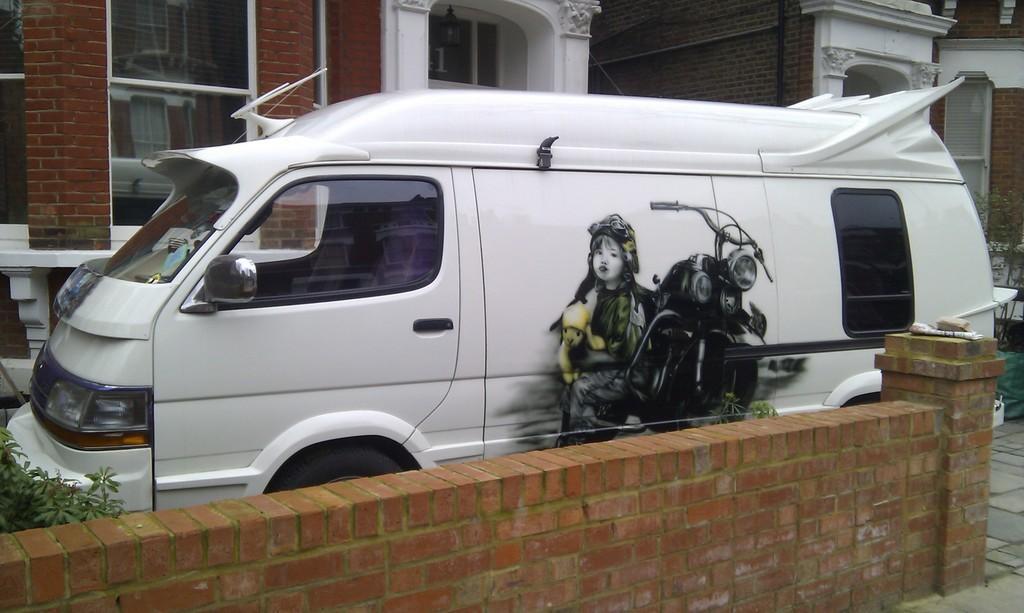In one or two sentences, can you explain what this image depicts? In the center of the image there is a van. At the bottom of the image there is a wall. In the background of the image there is a building. There is a window. 